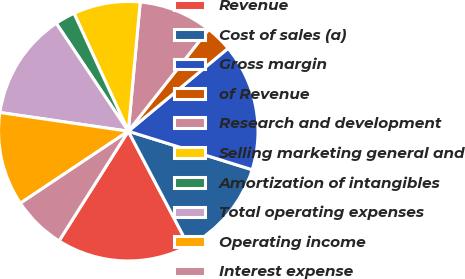Convert chart to OTSL. <chart><loc_0><loc_0><loc_500><loc_500><pie_chart><fcel>Revenue<fcel>Cost of sales (a)<fcel>Gross margin<fcel>of Revenue<fcel>Research and development<fcel>Selling marketing general and<fcel>Amortization of intangibles<fcel>Total operating expenses<fcel>Operating income<fcel>Interest expense<nl><fcel>16.67%<fcel>12.5%<fcel>15.83%<fcel>3.33%<fcel>9.17%<fcel>8.33%<fcel>2.5%<fcel>13.33%<fcel>11.67%<fcel>6.67%<nl></chart> 